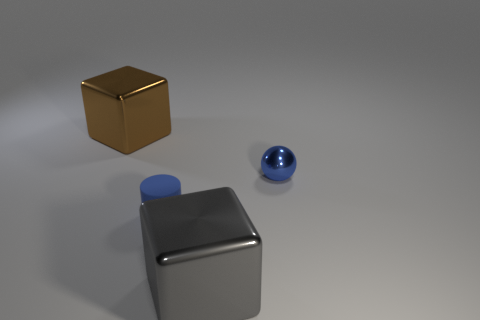Add 2 small blue metal spheres. How many objects exist? 6 Subtract all cylinders. How many objects are left? 3 Add 1 gray shiny cubes. How many gray shiny cubes are left? 2 Add 4 big gray objects. How many big gray objects exist? 5 Subtract 0 gray cylinders. How many objects are left? 4 Subtract all large gray blocks. Subtract all large metallic things. How many objects are left? 1 